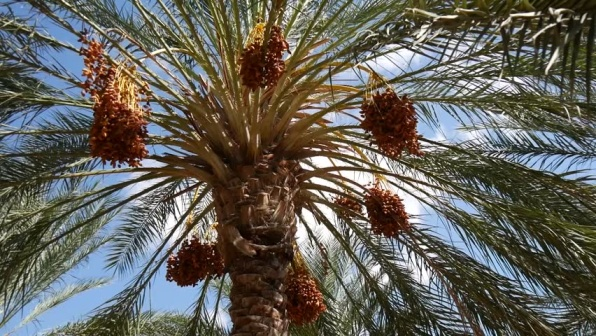What is the significance of the palm tree in cultural or religious contexts? The palm tree, specifically the date palm, holds immense cultural and religious significance. In Christianity, palm branches symbolize peace and were used to welcome Jesus into Jerusalem. In Islamic culture, date palms and their fruits are mentioned numerous times in the Quran, symbolizing life and fertility. They are also a staple during Ramadan for breaking the fast, providing quick energy after daylight hours of fasting. 